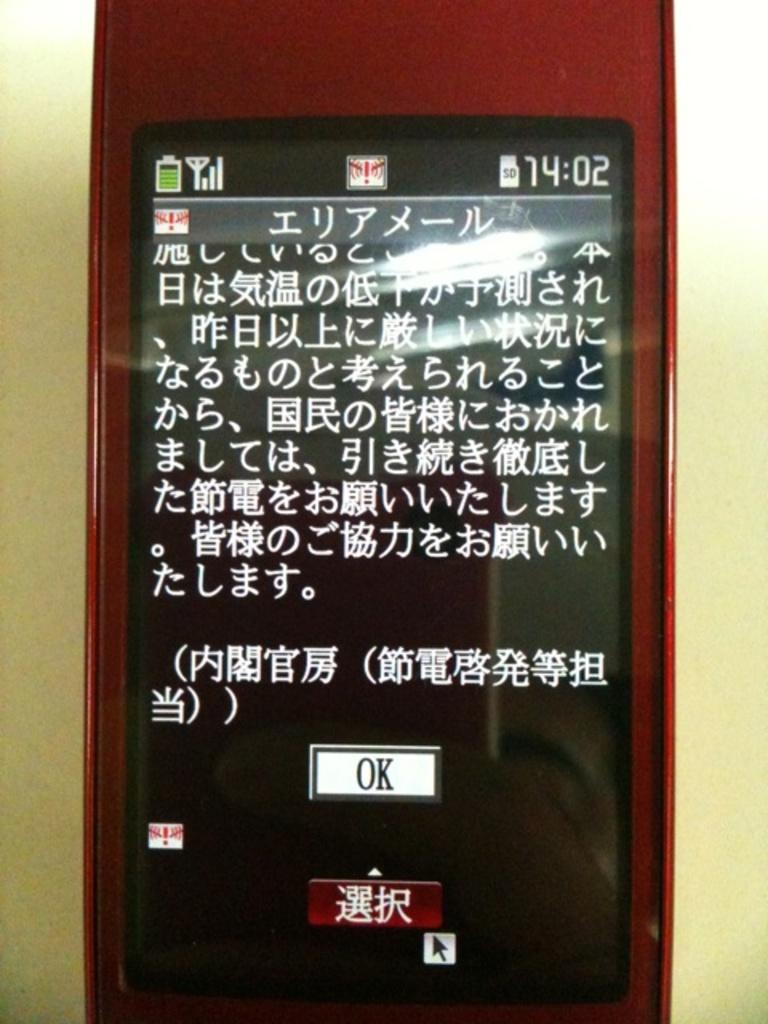Provide a one-sentence caption for the provided image. a cellphone with chinese characters and a white button labeled OK at the bottom center. 